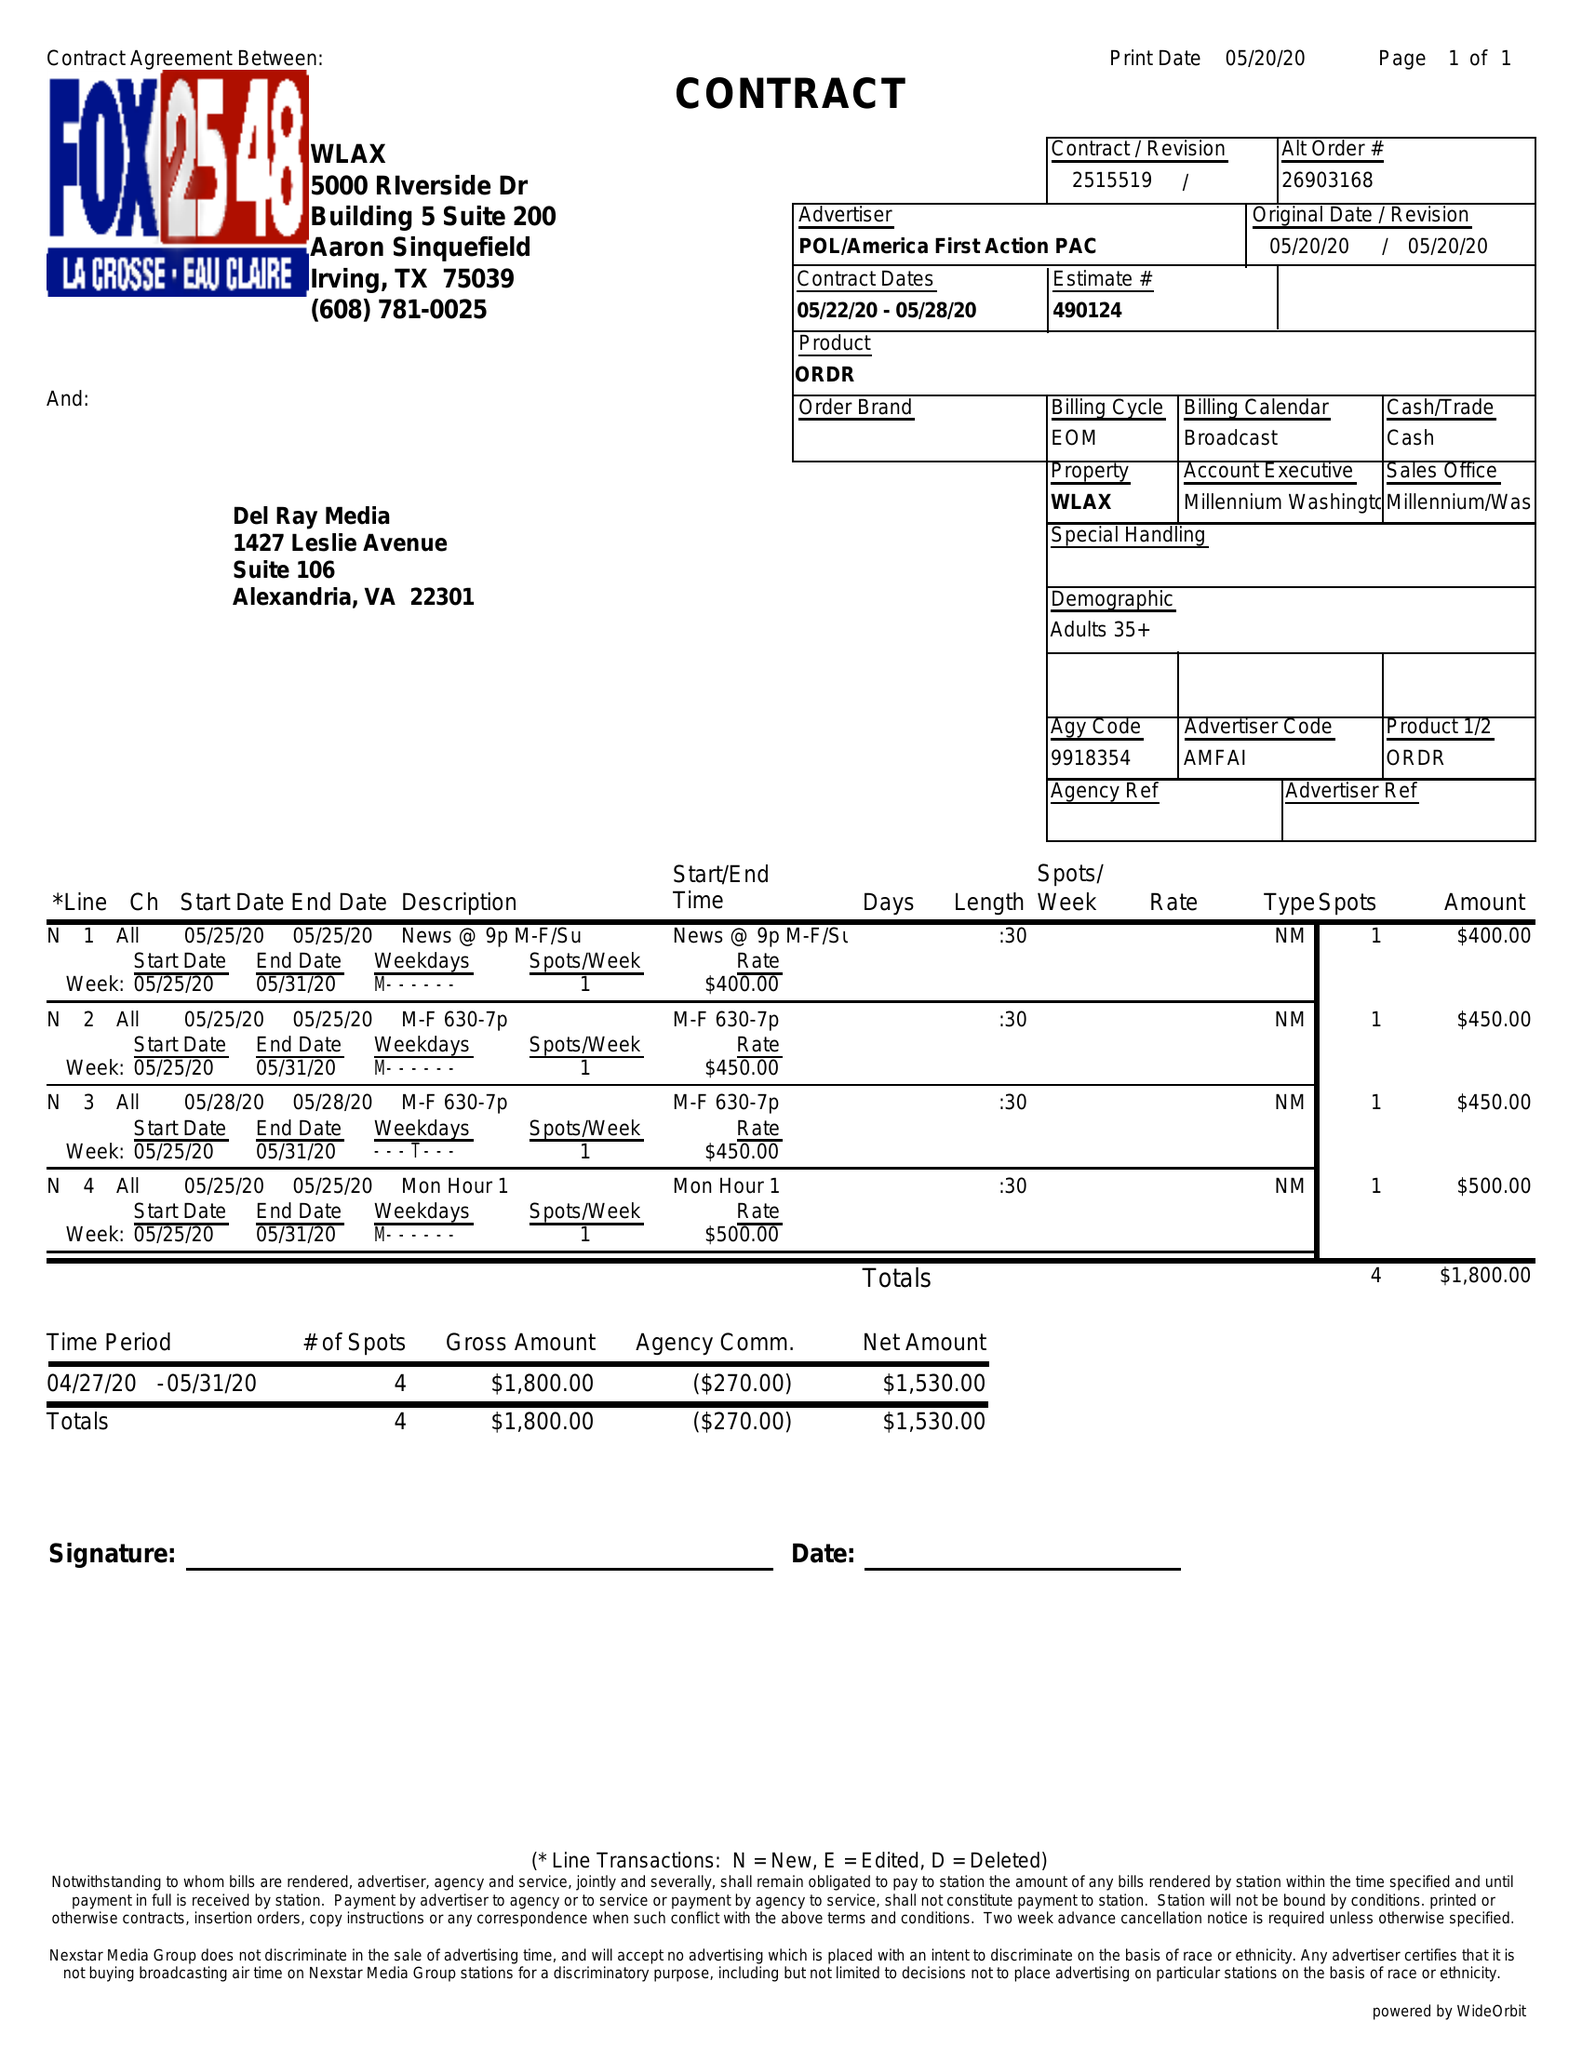What is the value for the contract_num?
Answer the question using a single word or phrase. 2515519 